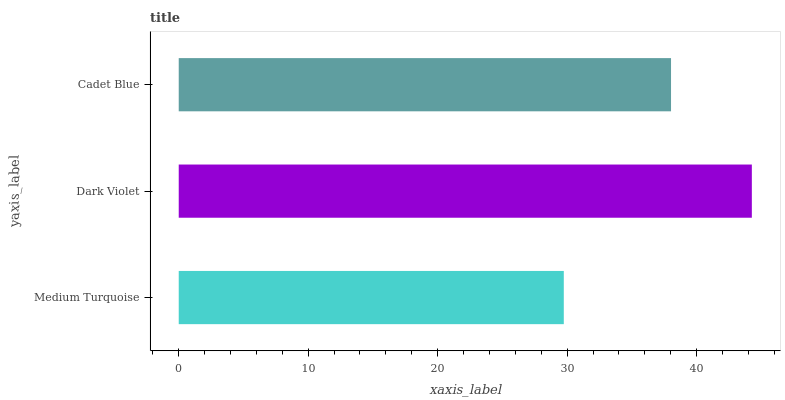Is Medium Turquoise the minimum?
Answer yes or no. Yes. Is Dark Violet the maximum?
Answer yes or no. Yes. Is Cadet Blue the minimum?
Answer yes or no. No. Is Cadet Blue the maximum?
Answer yes or no. No. Is Dark Violet greater than Cadet Blue?
Answer yes or no. Yes. Is Cadet Blue less than Dark Violet?
Answer yes or no. Yes. Is Cadet Blue greater than Dark Violet?
Answer yes or no. No. Is Dark Violet less than Cadet Blue?
Answer yes or no. No. Is Cadet Blue the high median?
Answer yes or no. Yes. Is Cadet Blue the low median?
Answer yes or no. Yes. Is Dark Violet the high median?
Answer yes or no. No. Is Dark Violet the low median?
Answer yes or no. No. 